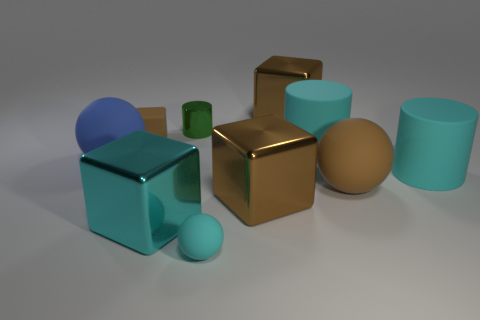Subtract all red spheres. How many brown cubes are left? 3 Subtract all brown cylinders. Subtract all purple blocks. How many cylinders are left? 3 Subtract all spheres. How many objects are left? 7 Add 7 cyan rubber things. How many cyan rubber things are left? 10 Add 1 large blue cubes. How many large blue cubes exist? 1 Subtract 0 purple blocks. How many objects are left? 10 Subtract all rubber balls. Subtract all small green objects. How many objects are left? 6 